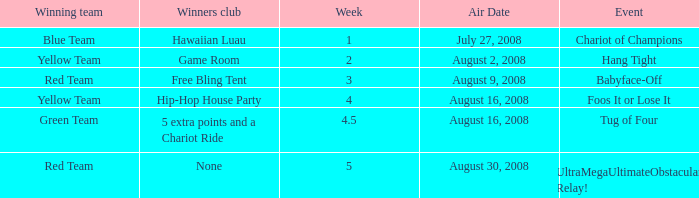Which Week has an Air Date of august 2, 2008? 2.0. 